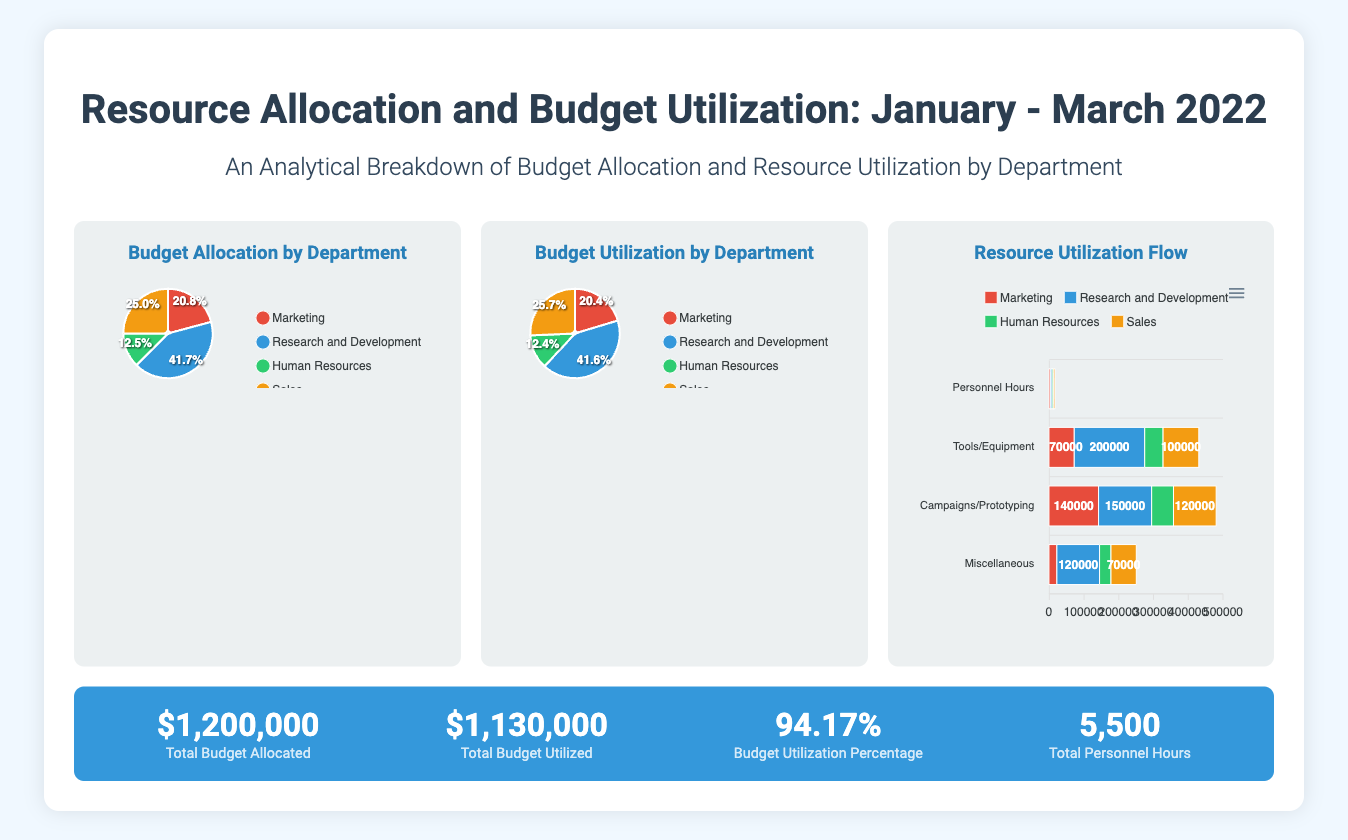What is the total budget allocated? The total budget allocated is presented in the metrics section of the poster, which shows $1,200,000.
Answer: $1,200,000 What is the total budget utilized? The total budget utilized is listed in the metrics section, which states $1,130,000.
Answer: $1,130,000 What is the budget utilization percentage? The budget utilization percentage can be found in the metrics section as 94.17%.
Answer: 94.17% How many total personnel hours were reported? The total personnel hours are mentioned in the metrics section, which indicates 5,500 hours.
Answer: 5,500 Which department received the highest budget allocation? The budget allocation pie chart visualizes the distribution, showing that Sales had the highest allocation at $300,000.
Answer: Sales What was the budget utilization for Research and Development? The budget utilization pie chart indicates that Research and Development utilized $470,000.
Answer: $470,000 How many categories are presented in the resource utilization flow chart? The resource utilization flow chart lists four categories: Personnel Hours, Tools/Equipment, Campaigns/Prototyping, and Miscellaneous.
Answer: Four What color represents Marketing in the charts? The color associated with Marketing in the pie charts is red (#e74c3c).
Answer: Red What type of chart is used for budget utilization? The type of chart used for budget utilization is a pie chart.
Answer: Pie Chart 